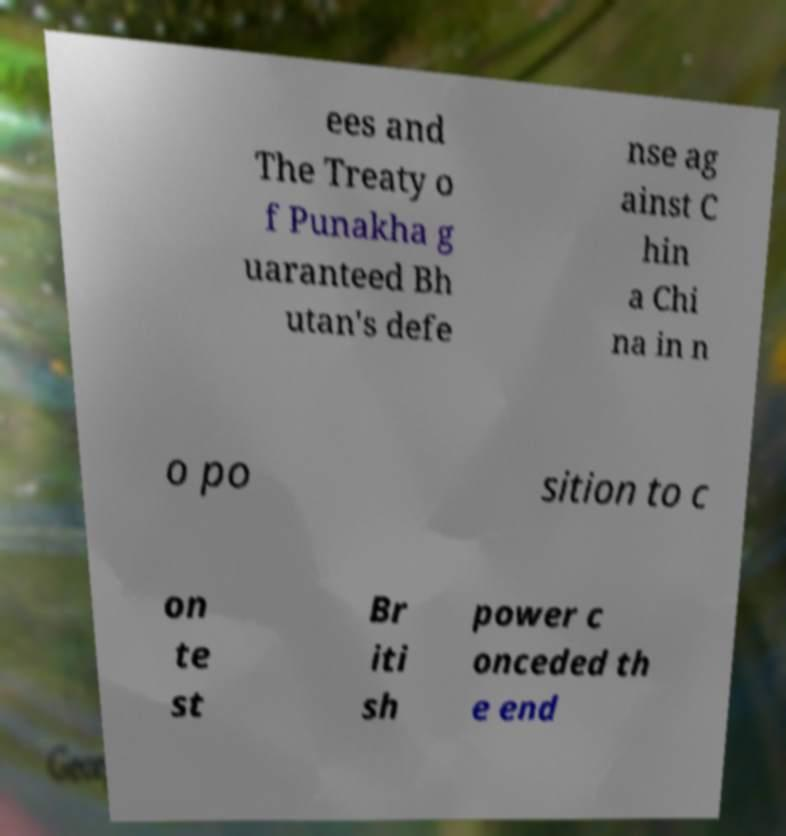Could you assist in decoding the text presented in this image and type it out clearly? ees and The Treaty o f Punakha g uaranteed Bh utan's defe nse ag ainst C hin a Chi na in n o po sition to c on te st Br iti sh power c onceded th e end 